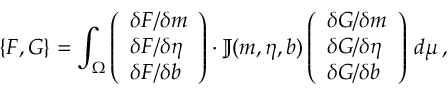<formula> <loc_0><loc_0><loc_500><loc_500>\{ F , G \} = \int _ { \Omega } \left ( \begin{array} { l } { \delta F / \delta m } \\ { \delta F / \delta \eta } \\ { \delta F / \delta b } \end{array} \right ) \cdot \mathbb { J } ( m , \eta , b ) \left ( \begin{array} { l } { \delta G / \delta m } \\ { \delta G / \delta \eta } \\ { \delta G / \delta b } \end{array} \right ) \, d \mu \, ,</formula> 